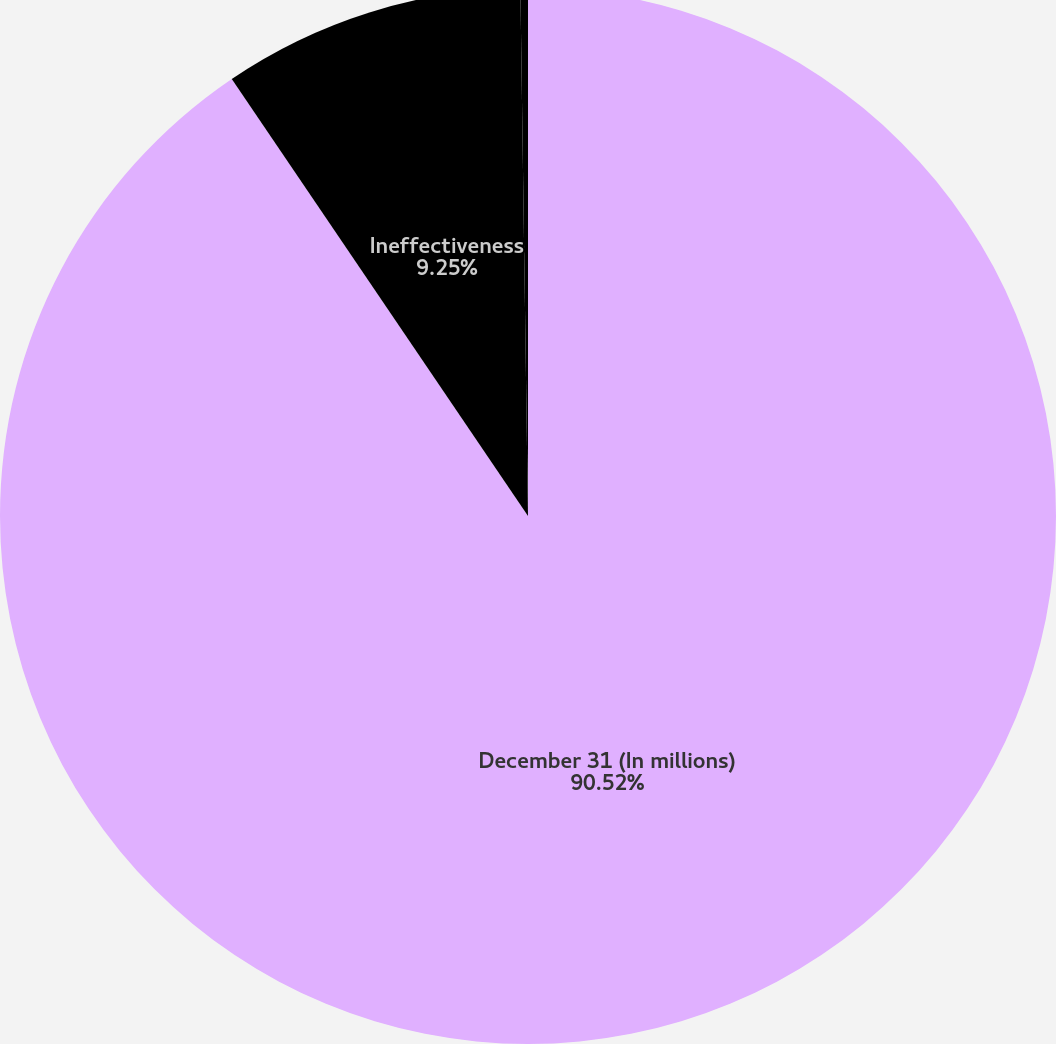Convert chart to OTSL. <chart><loc_0><loc_0><loc_500><loc_500><pie_chart><fcel>December 31 (In millions)<fcel>Ineffectiveness<fcel>Amounts excluded from the<nl><fcel>90.52%<fcel>9.25%<fcel>0.23%<nl></chart> 